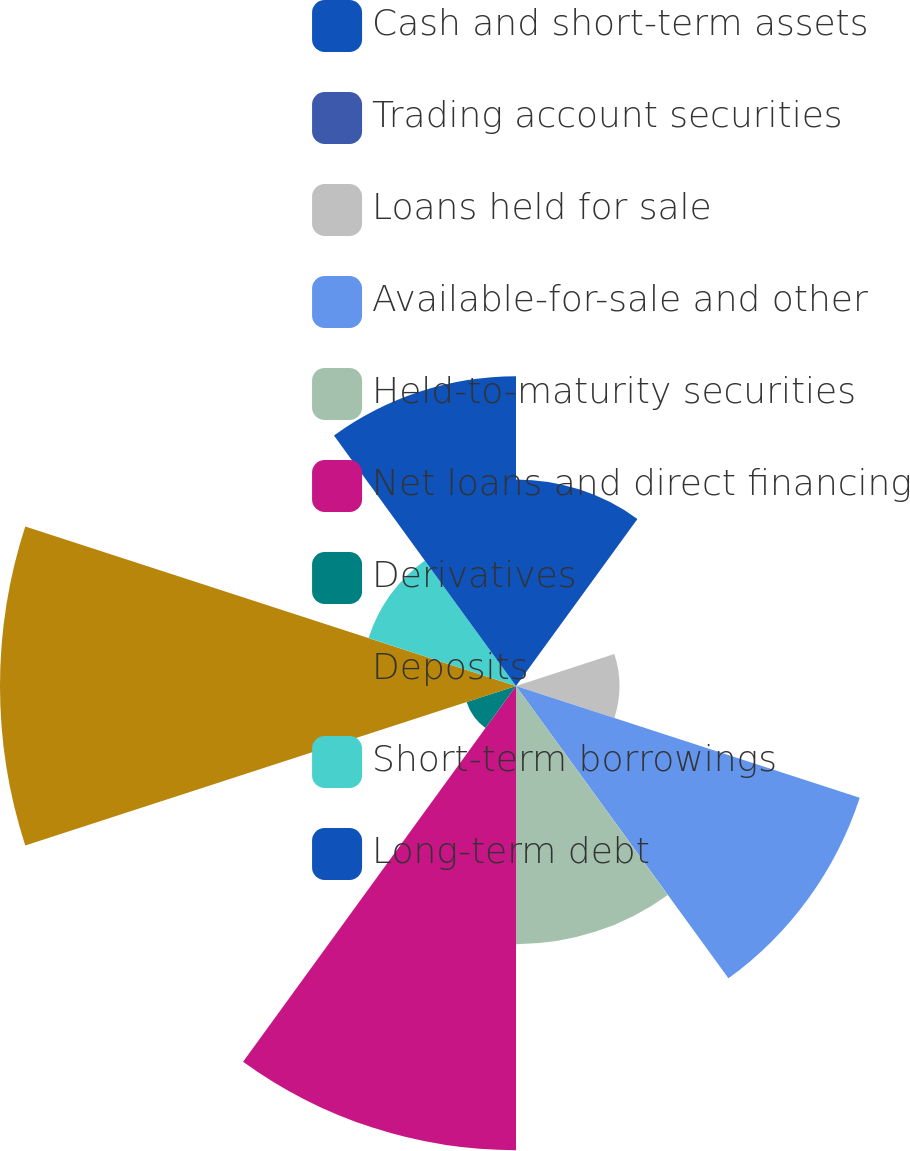Convert chart to OTSL. <chart><loc_0><loc_0><loc_500><loc_500><pie_chart><fcel>Cash and short-term assets<fcel>Trading account securities<fcel>Loans held for sale<fcel>Available-for-sale and other<fcel>Held-to-maturity securities<fcel>Net loans and direct financing<fcel>Derivatives<fcel>Deposits<fcel>Short-term borrowings<fcel>Long-term debt<nl><fcel>8.51%<fcel>0.01%<fcel>4.26%<fcel>14.89%<fcel>10.64%<fcel>19.13%<fcel>2.14%<fcel>21.26%<fcel>6.39%<fcel>12.76%<nl></chart> 